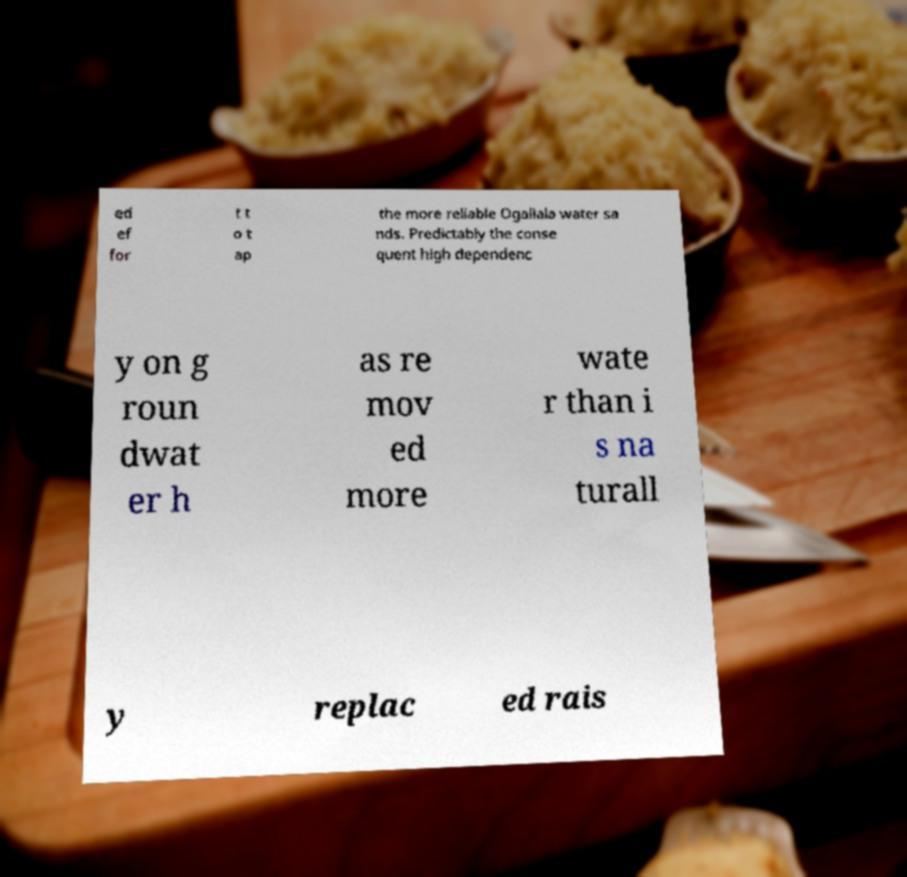I need the written content from this picture converted into text. Can you do that? ed ef for t t o t ap the more reliable Ogallala water sa nds. Predictably the conse quent high dependenc y on g roun dwat er h as re mov ed more wate r than i s na turall y replac ed rais 